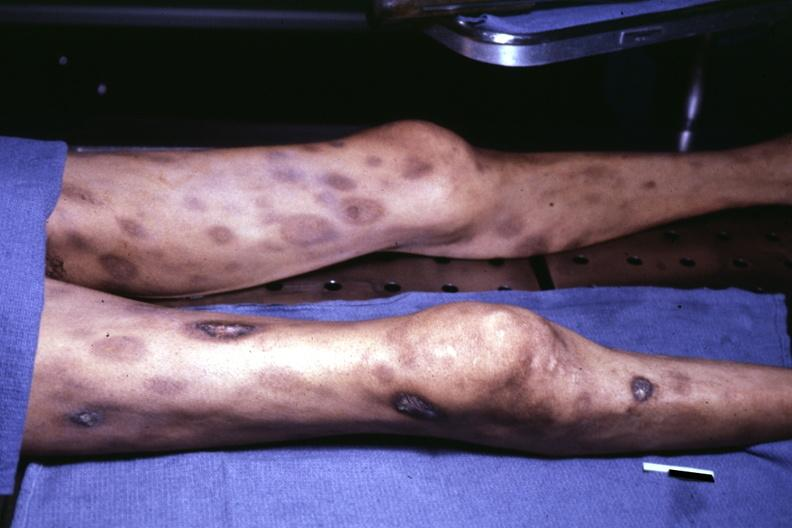what ecchymoses with central necrosis?
Answer the question using a single word or phrase. View of thighs and legs at autopsy 